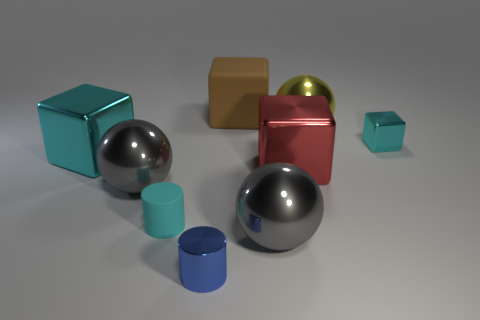Subtract all blocks. How many objects are left? 5 Subtract 0 purple cylinders. How many objects are left? 9 Subtract all big matte blocks. Subtract all tiny blue metal things. How many objects are left? 7 Add 1 cylinders. How many cylinders are left? 3 Add 6 cylinders. How many cylinders exist? 8 